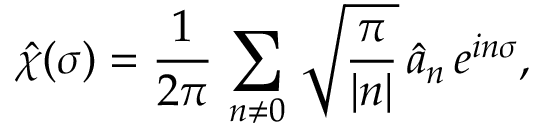Convert formula to latex. <formula><loc_0><loc_0><loc_500><loc_500>\hat { \chi } ( \sigma ) = \frac { 1 } { 2 \pi } \, \sum _ { n \ne 0 } \, \sqrt { \frac { \pi } { | n | } } \, \hat { a } _ { n } \, e ^ { i n \sigma } ,</formula> 